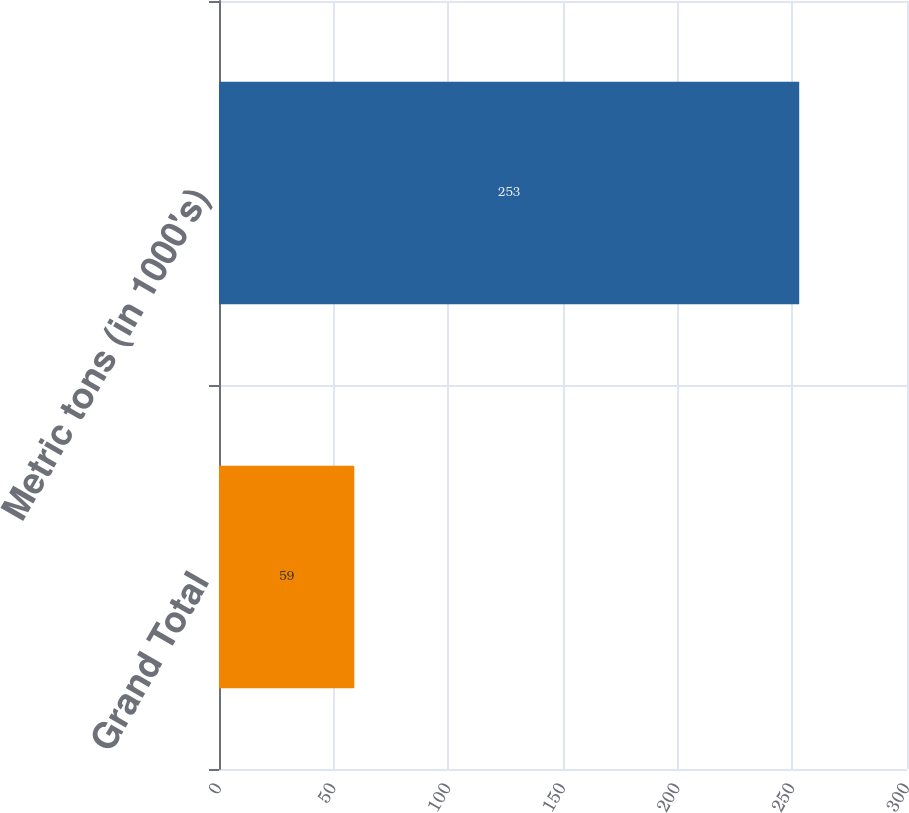Convert chart. <chart><loc_0><loc_0><loc_500><loc_500><bar_chart><fcel>Grand Total<fcel>Metric tons (in 1000's)<nl><fcel>59<fcel>253<nl></chart> 